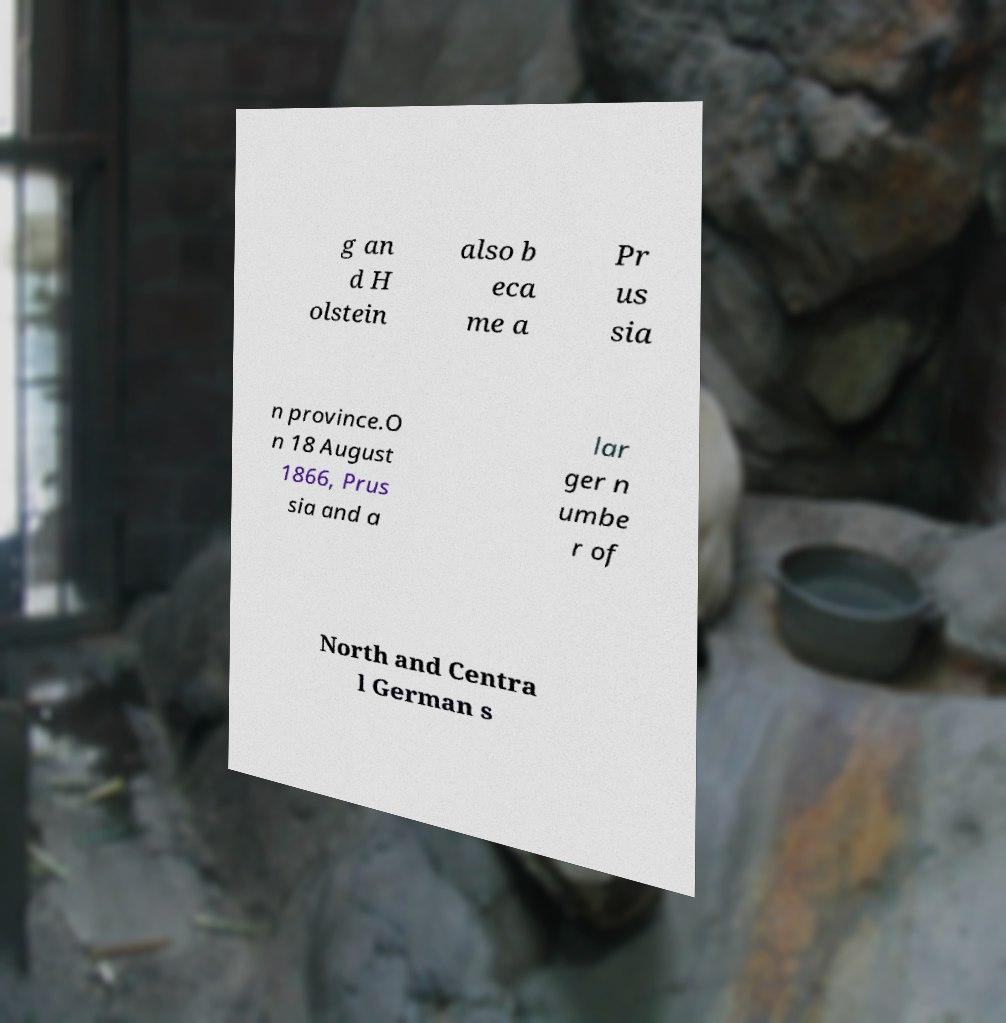Can you accurately transcribe the text from the provided image for me? g an d H olstein also b eca me a Pr us sia n province.O n 18 August 1866, Prus sia and a lar ger n umbe r of North and Centra l German s 